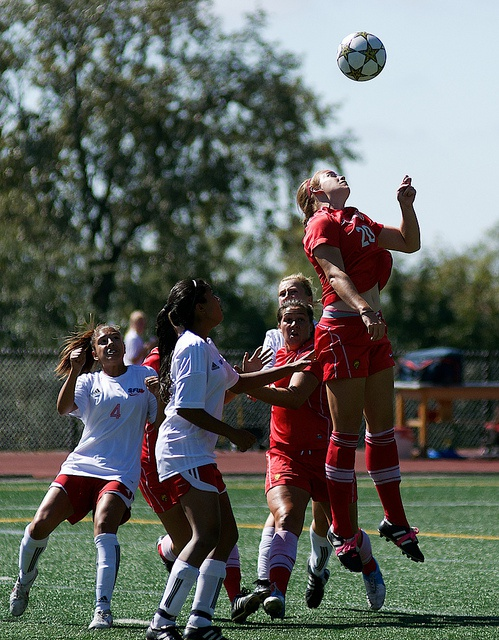Describe the objects in this image and their specific colors. I can see people in darkgray, black, maroon, gray, and lightgray tones, people in darkgray, black, gray, and white tones, people in darkgray, black, gray, and white tones, people in darkgray, black, maroon, lightgray, and navy tones, and people in darkgray, black, maroon, gray, and lavender tones in this image. 